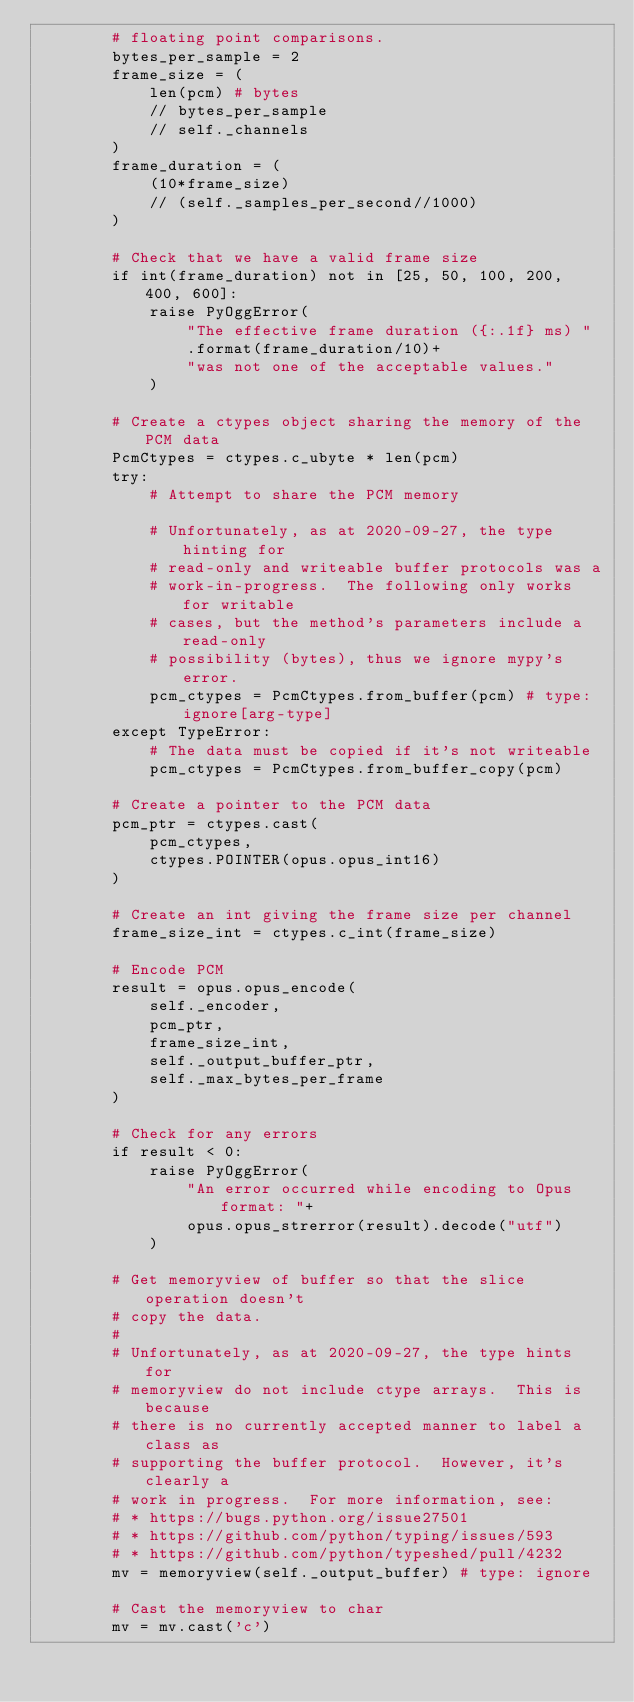Convert code to text. <code><loc_0><loc_0><loc_500><loc_500><_Python_>        # floating point comparisons.
        bytes_per_sample = 2
        frame_size = (
            len(pcm) # bytes
            // bytes_per_sample
            // self._channels
        )
        frame_duration = (
            (10*frame_size)
            // (self._samples_per_second//1000)
        )

        # Check that we have a valid frame size
        if int(frame_duration) not in [25, 50, 100, 200, 400, 600]:
            raise PyOggError(
                "The effective frame duration ({:.1f} ms) "
                .format(frame_duration/10)+
                "was not one of the acceptable values."
            )

        # Create a ctypes object sharing the memory of the PCM data
        PcmCtypes = ctypes.c_ubyte * len(pcm)
        try:
            # Attempt to share the PCM memory
            
            # Unfortunately, as at 2020-09-27, the type hinting for
            # read-only and writeable buffer protocols was a
            # work-in-progress.  The following only works for writable
            # cases, but the method's parameters include a read-only
            # possibility (bytes), thus we ignore mypy's error.
            pcm_ctypes = PcmCtypes.from_buffer(pcm) # type: ignore[arg-type]
        except TypeError:
            # The data must be copied if it's not writeable
            pcm_ctypes = PcmCtypes.from_buffer_copy(pcm)

        # Create a pointer to the PCM data
        pcm_ptr = ctypes.cast(
            pcm_ctypes,
            ctypes.POINTER(opus.opus_int16)
        )

        # Create an int giving the frame size per channel
        frame_size_int = ctypes.c_int(frame_size)

        # Encode PCM
        result = opus.opus_encode(
            self._encoder,
            pcm_ptr,
            frame_size_int,
            self._output_buffer_ptr,
            self._max_bytes_per_frame
        )

        # Check for any errors
        if result < 0:
            raise PyOggError(
                "An error occurred while encoding to Opus format: "+
                opus.opus_strerror(result).decode("utf")
            )

        # Get memoryview of buffer so that the slice operation doesn't
        # copy the data.
        #
        # Unfortunately, as at 2020-09-27, the type hints for
        # memoryview do not include ctype arrays.  This is because
        # there is no currently accepted manner to label a class as
        # supporting the buffer protocol.  However, it's clearly a
        # work in progress.  For more information, see:
        # * https://bugs.python.org/issue27501
        # * https://github.com/python/typing/issues/593
        # * https://github.com/python/typeshed/pull/4232
        mv = memoryview(self._output_buffer) # type: ignore
        
        # Cast the memoryview to char
        mv = mv.cast('c')
</code> 